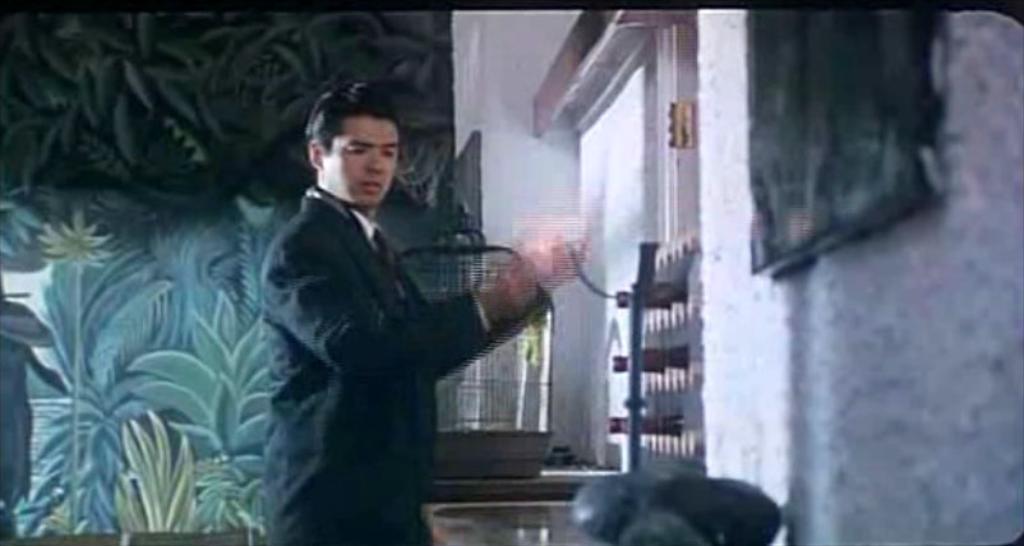Please provide a concise description of this image. In this picture we can see a man is standing on the path and behind the man there is a cage on an object and wall. 